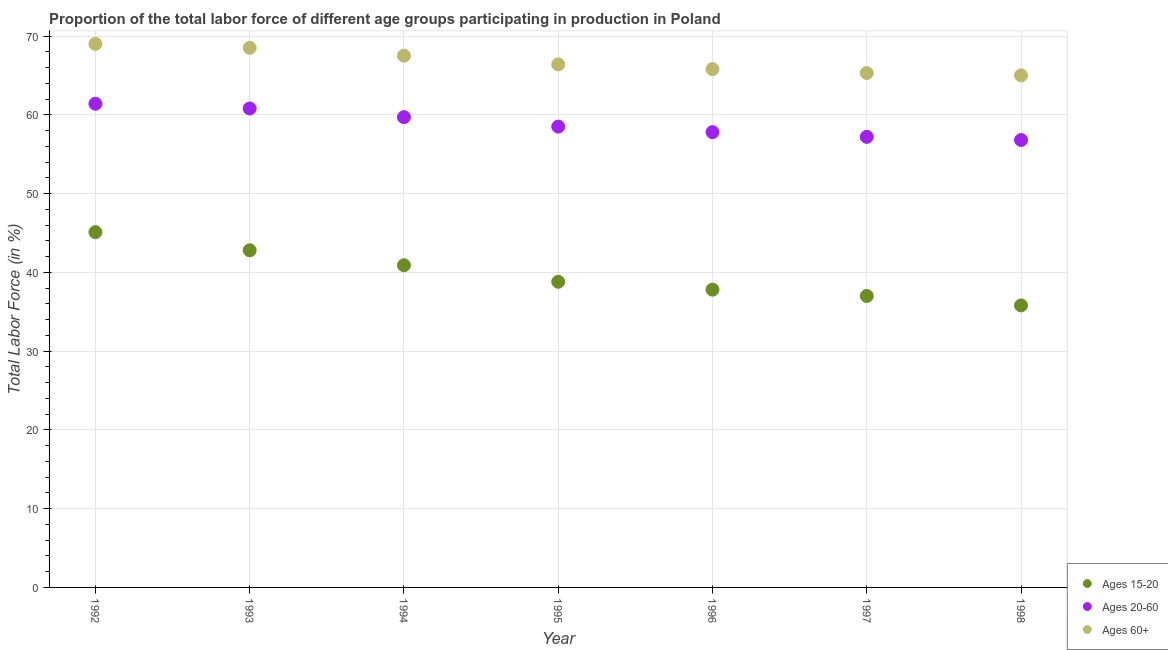What is the percentage of labor force above age 60 in 1996?
Give a very brief answer. 65.8. Across all years, what is the maximum percentage of labor force within the age group 15-20?
Keep it short and to the point. 45.1. Across all years, what is the minimum percentage of labor force within the age group 15-20?
Your response must be concise. 35.8. What is the total percentage of labor force within the age group 20-60 in the graph?
Provide a succinct answer. 412.2. What is the difference between the percentage of labor force within the age group 15-20 in 1994 and that in 1996?
Ensure brevity in your answer.  3.1. What is the difference between the percentage of labor force within the age group 15-20 in 1997 and the percentage of labor force above age 60 in 1994?
Offer a terse response. -30.5. What is the average percentage of labor force within the age group 20-60 per year?
Your answer should be very brief. 58.89. In the year 1997, what is the difference between the percentage of labor force above age 60 and percentage of labor force within the age group 15-20?
Ensure brevity in your answer.  28.3. In how many years, is the percentage of labor force above age 60 greater than 54 %?
Ensure brevity in your answer.  7. What is the ratio of the percentage of labor force within the age group 15-20 in 1993 to that in 1997?
Ensure brevity in your answer.  1.16. Is the percentage of labor force within the age group 15-20 in 1996 less than that in 1998?
Make the answer very short. No. What is the difference between the highest and the second highest percentage of labor force within the age group 15-20?
Your response must be concise. 2.3. What is the difference between the highest and the lowest percentage of labor force above age 60?
Provide a succinct answer. 4. Is the sum of the percentage of labor force within the age group 20-60 in 1994 and 1995 greater than the maximum percentage of labor force above age 60 across all years?
Provide a succinct answer. Yes. Does the percentage of labor force above age 60 monotonically increase over the years?
Keep it short and to the point. No. Is the percentage of labor force above age 60 strictly less than the percentage of labor force within the age group 20-60 over the years?
Your response must be concise. No. How many years are there in the graph?
Ensure brevity in your answer.  7. How are the legend labels stacked?
Your response must be concise. Vertical. What is the title of the graph?
Offer a terse response. Proportion of the total labor force of different age groups participating in production in Poland. Does "Social Protection and Labor" appear as one of the legend labels in the graph?
Offer a very short reply. No. What is the Total Labor Force (in %) in Ages 15-20 in 1992?
Make the answer very short. 45.1. What is the Total Labor Force (in %) in Ages 20-60 in 1992?
Your answer should be very brief. 61.4. What is the Total Labor Force (in %) of Ages 15-20 in 1993?
Your answer should be compact. 42.8. What is the Total Labor Force (in %) in Ages 20-60 in 1993?
Provide a succinct answer. 60.8. What is the Total Labor Force (in %) of Ages 60+ in 1993?
Give a very brief answer. 68.5. What is the Total Labor Force (in %) of Ages 15-20 in 1994?
Your answer should be compact. 40.9. What is the Total Labor Force (in %) in Ages 20-60 in 1994?
Give a very brief answer. 59.7. What is the Total Labor Force (in %) of Ages 60+ in 1994?
Provide a succinct answer. 67.5. What is the Total Labor Force (in %) in Ages 15-20 in 1995?
Ensure brevity in your answer.  38.8. What is the Total Labor Force (in %) of Ages 20-60 in 1995?
Make the answer very short. 58.5. What is the Total Labor Force (in %) in Ages 60+ in 1995?
Provide a short and direct response. 66.4. What is the Total Labor Force (in %) of Ages 15-20 in 1996?
Offer a terse response. 37.8. What is the Total Labor Force (in %) of Ages 20-60 in 1996?
Offer a terse response. 57.8. What is the Total Labor Force (in %) of Ages 60+ in 1996?
Offer a very short reply. 65.8. What is the Total Labor Force (in %) in Ages 15-20 in 1997?
Make the answer very short. 37. What is the Total Labor Force (in %) of Ages 20-60 in 1997?
Offer a terse response. 57.2. What is the Total Labor Force (in %) in Ages 60+ in 1997?
Your answer should be very brief. 65.3. What is the Total Labor Force (in %) in Ages 15-20 in 1998?
Make the answer very short. 35.8. What is the Total Labor Force (in %) in Ages 20-60 in 1998?
Offer a terse response. 56.8. Across all years, what is the maximum Total Labor Force (in %) of Ages 15-20?
Provide a short and direct response. 45.1. Across all years, what is the maximum Total Labor Force (in %) in Ages 20-60?
Provide a short and direct response. 61.4. Across all years, what is the minimum Total Labor Force (in %) of Ages 15-20?
Your answer should be very brief. 35.8. Across all years, what is the minimum Total Labor Force (in %) of Ages 20-60?
Provide a short and direct response. 56.8. What is the total Total Labor Force (in %) in Ages 15-20 in the graph?
Provide a succinct answer. 278.2. What is the total Total Labor Force (in %) in Ages 20-60 in the graph?
Provide a short and direct response. 412.2. What is the total Total Labor Force (in %) in Ages 60+ in the graph?
Keep it short and to the point. 467.5. What is the difference between the Total Labor Force (in %) of Ages 15-20 in 1992 and that in 1993?
Your answer should be compact. 2.3. What is the difference between the Total Labor Force (in %) of Ages 60+ in 1992 and that in 1993?
Keep it short and to the point. 0.5. What is the difference between the Total Labor Force (in %) of Ages 15-20 in 1992 and that in 1994?
Offer a terse response. 4.2. What is the difference between the Total Labor Force (in %) in Ages 20-60 in 1992 and that in 1994?
Your response must be concise. 1.7. What is the difference between the Total Labor Force (in %) of Ages 60+ in 1992 and that in 1994?
Offer a terse response. 1.5. What is the difference between the Total Labor Force (in %) of Ages 20-60 in 1992 and that in 1996?
Give a very brief answer. 3.6. What is the difference between the Total Labor Force (in %) of Ages 60+ in 1992 and that in 1996?
Your response must be concise. 3.2. What is the difference between the Total Labor Force (in %) of Ages 15-20 in 1992 and that in 1998?
Offer a very short reply. 9.3. What is the difference between the Total Labor Force (in %) in Ages 20-60 in 1992 and that in 1998?
Provide a succinct answer. 4.6. What is the difference between the Total Labor Force (in %) of Ages 15-20 in 1993 and that in 1994?
Give a very brief answer. 1.9. What is the difference between the Total Labor Force (in %) of Ages 60+ in 1993 and that in 1994?
Make the answer very short. 1. What is the difference between the Total Labor Force (in %) of Ages 15-20 in 1993 and that in 1996?
Offer a terse response. 5. What is the difference between the Total Labor Force (in %) of Ages 60+ in 1993 and that in 1996?
Keep it short and to the point. 2.7. What is the difference between the Total Labor Force (in %) in Ages 20-60 in 1993 and that in 1997?
Your answer should be compact. 3.6. What is the difference between the Total Labor Force (in %) of Ages 60+ in 1993 and that in 1997?
Make the answer very short. 3.2. What is the difference between the Total Labor Force (in %) of Ages 15-20 in 1993 and that in 1998?
Make the answer very short. 7. What is the difference between the Total Labor Force (in %) in Ages 20-60 in 1994 and that in 1995?
Give a very brief answer. 1.2. What is the difference between the Total Labor Force (in %) in Ages 60+ in 1994 and that in 1995?
Your response must be concise. 1.1. What is the difference between the Total Labor Force (in %) of Ages 20-60 in 1994 and that in 1996?
Make the answer very short. 1.9. What is the difference between the Total Labor Force (in %) of Ages 60+ in 1994 and that in 1996?
Offer a very short reply. 1.7. What is the difference between the Total Labor Force (in %) in Ages 20-60 in 1994 and that in 1997?
Offer a terse response. 2.5. What is the difference between the Total Labor Force (in %) of Ages 15-20 in 1994 and that in 1998?
Provide a short and direct response. 5.1. What is the difference between the Total Labor Force (in %) in Ages 60+ in 1995 and that in 1996?
Offer a very short reply. 0.6. What is the difference between the Total Labor Force (in %) of Ages 15-20 in 1995 and that in 1998?
Your answer should be very brief. 3. What is the difference between the Total Labor Force (in %) in Ages 20-60 in 1995 and that in 1998?
Give a very brief answer. 1.7. What is the difference between the Total Labor Force (in %) of Ages 60+ in 1995 and that in 1998?
Keep it short and to the point. 1.4. What is the difference between the Total Labor Force (in %) of Ages 15-20 in 1996 and that in 1997?
Offer a terse response. 0.8. What is the difference between the Total Labor Force (in %) of Ages 15-20 in 1996 and that in 1998?
Your answer should be very brief. 2. What is the difference between the Total Labor Force (in %) of Ages 20-60 in 1996 and that in 1998?
Provide a succinct answer. 1. What is the difference between the Total Labor Force (in %) of Ages 60+ in 1996 and that in 1998?
Your answer should be very brief. 0.8. What is the difference between the Total Labor Force (in %) of Ages 15-20 in 1997 and that in 1998?
Provide a short and direct response. 1.2. What is the difference between the Total Labor Force (in %) in Ages 60+ in 1997 and that in 1998?
Make the answer very short. 0.3. What is the difference between the Total Labor Force (in %) in Ages 15-20 in 1992 and the Total Labor Force (in %) in Ages 20-60 in 1993?
Your response must be concise. -15.7. What is the difference between the Total Labor Force (in %) of Ages 15-20 in 1992 and the Total Labor Force (in %) of Ages 60+ in 1993?
Offer a terse response. -23.4. What is the difference between the Total Labor Force (in %) of Ages 15-20 in 1992 and the Total Labor Force (in %) of Ages 20-60 in 1994?
Your answer should be compact. -14.6. What is the difference between the Total Labor Force (in %) in Ages 15-20 in 1992 and the Total Labor Force (in %) in Ages 60+ in 1994?
Provide a succinct answer. -22.4. What is the difference between the Total Labor Force (in %) of Ages 20-60 in 1992 and the Total Labor Force (in %) of Ages 60+ in 1994?
Make the answer very short. -6.1. What is the difference between the Total Labor Force (in %) of Ages 15-20 in 1992 and the Total Labor Force (in %) of Ages 60+ in 1995?
Your response must be concise. -21.3. What is the difference between the Total Labor Force (in %) of Ages 15-20 in 1992 and the Total Labor Force (in %) of Ages 60+ in 1996?
Provide a succinct answer. -20.7. What is the difference between the Total Labor Force (in %) in Ages 15-20 in 1992 and the Total Labor Force (in %) in Ages 60+ in 1997?
Provide a succinct answer. -20.2. What is the difference between the Total Labor Force (in %) in Ages 15-20 in 1992 and the Total Labor Force (in %) in Ages 20-60 in 1998?
Your answer should be compact. -11.7. What is the difference between the Total Labor Force (in %) in Ages 15-20 in 1992 and the Total Labor Force (in %) in Ages 60+ in 1998?
Your answer should be very brief. -19.9. What is the difference between the Total Labor Force (in %) in Ages 20-60 in 1992 and the Total Labor Force (in %) in Ages 60+ in 1998?
Your answer should be compact. -3.6. What is the difference between the Total Labor Force (in %) in Ages 15-20 in 1993 and the Total Labor Force (in %) in Ages 20-60 in 1994?
Make the answer very short. -16.9. What is the difference between the Total Labor Force (in %) of Ages 15-20 in 1993 and the Total Labor Force (in %) of Ages 60+ in 1994?
Your response must be concise. -24.7. What is the difference between the Total Labor Force (in %) in Ages 15-20 in 1993 and the Total Labor Force (in %) in Ages 20-60 in 1995?
Give a very brief answer. -15.7. What is the difference between the Total Labor Force (in %) of Ages 15-20 in 1993 and the Total Labor Force (in %) of Ages 60+ in 1995?
Ensure brevity in your answer.  -23.6. What is the difference between the Total Labor Force (in %) of Ages 15-20 in 1993 and the Total Labor Force (in %) of Ages 20-60 in 1996?
Give a very brief answer. -15. What is the difference between the Total Labor Force (in %) of Ages 20-60 in 1993 and the Total Labor Force (in %) of Ages 60+ in 1996?
Make the answer very short. -5. What is the difference between the Total Labor Force (in %) in Ages 15-20 in 1993 and the Total Labor Force (in %) in Ages 20-60 in 1997?
Offer a terse response. -14.4. What is the difference between the Total Labor Force (in %) in Ages 15-20 in 1993 and the Total Labor Force (in %) in Ages 60+ in 1997?
Keep it short and to the point. -22.5. What is the difference between the Total Labor Force (in %) of Ages 15-20 in 1993 and the Total Labor Force (in %) of Ages 60+ in 1998?
Your response must be concise. -22.2. What is the difference between the Total Labor Force (in %) in Ages 15-20 in 1994 and the Total Labor Force (in %) in Ages 20-60 in 1995?
Ensure brevity in your answer.  -17.6. What is the difference between the Total Labor Force (in %) of Ages 15-20 in 1994 and the Total Labor Force (in %) of Ages 60+ in 1995?
Ensure brevity in your answer.  -25.5. What is the difference between the Total Labor Force (in %) in Ages 15-20 in 1994 and the Total Labor Force (in %) in Ages 20-60 in 1996?
Keep it short and to the point. -16.9. What is the difference between the Total Labor Force (in %) of Ages 15-20 in 1994 and the Total Labor Force (in %) of Ages 60+ in 1996?
Offer a very short reply. -24.9. What is the difference between the Total Labor Force (in %) of Ages 15-20 in 1994 and the Total Labor Force (in %) of Ages 20-60 in 1997?
Ensure brevity in your answer.  -16.3. What is the difference between the Total Labor Force (in %) of Ages 15-20 in 1994 and the Total Labor Force (in %) of Ages 60+ in 1997?
Make the answer very short. -24.4. What is the difference between the Total Labor Force (in %) in Ages 20-60 in 1994 and the Total Labor Force (in %) in Ages 60+ in 1997?
Your answer should be compact. -5.6. What is the difference between the Total Labor Force (in %) of Ages 15-20 in 1994 and the Total Labor Force (in %) of Ages 20-60 in 1998?
Your response must be concise. -15.9. What is the difference between the Total Labor Force (in %) in Ages 15-20 in 1994 and the Total Labor Force (in %) in Ages 60+ in 1998?
Give a very brief answer. -24.1. What is the difference between the Total Labor Force (in %) of Ages 15-20 in 1995 and the Total Labor Force (in %) of Ages 60+ in 1996?
Provide a short and direct response. -27. What is the difference between the Total Labor Force (in %) in Ages 15-20 in 1995 and the Total Labor Force (in %) in Ages 20-60 in 1997?
Your answer should be compact. -18.4. What is the difference between the Total Labor Force (in %) in Ages 15-20 in 1995 and the Total Labor Force (in %) in Ages 60+ in 1997?
Your response must be concise. -26.5. What is the difference between the Total Labor Force (in %) in Ages 15-20 in 1995 and the Total Labor Force (in %) in Ages 20-60 in 1998?
Your response must be concise. -18. What is the difference between the Total Labor Force (in %) in Ages 15-20 in 1995 and the Total Labor Force (in %) in Ages 60+ in 1998?
Provide a short and direct response. -26.2. What is the difference between the Total Labor Force (in %) in Ages 20-60 in 1995 and the Total Labor Force (in %) in Ages 60+ in 1998?
Ensure brevity in your answer.  -6.5. What is the difference between the Total Labor Force (in %) of Ages 15-20 in 1996 and the Total Labor Force (in %) of Ages 20-60 in 1997?
Make the answer very short. -19.4. What is the difference between the Total Labor Force (in %) in Ages 15-20 in 1996 and the Total Labor Force (in %) in Ages 60+ in 1997?
Keep it short and to the point. -27.5. What is the difference between the Total Labor Force (in %) of Ages 15-20 in 1996 and the Total Labor Force (in %) of Ages 20-60 in 1998?
Ensure brevity in your answer.  -19. What is the difference between the Total Labor Force (in %) in Ages 15-20 in 1996 and the Total Labor Force (in %) in Ages 60+ in 1998?
Offer a very short reply. -27.2. What is the difference between the Total Labor Force (in %) of Ages 15-20 in 1997 and the Total Labor Force (in %) of Ages 20-60 in 1998?
Provide a succinct answer. -19.8. What is the difference between the Total Labor Force (in %) in Ages 15-20 in 1997 and the Total Labor Force (in %) in Ages 60+ in 1998?
Provide a short and direct response. -28. What is the difference between the Total Labor Force (in %) of Ages 20-60 in 1997 and the Total Labor Force (in %) of Ages 60+ in 1998?
Your answer should be very brief. -7.8. What is the average Total Labor Force (in %) in Ages 15-20 per year?
Ensure brevity in your answer.  39.74. What is the average Total Labor Force (in %) in Ages 20-60 per year?
Your response must be concise. 58.89. What is the average Total Labor Force (in %) of Ages 60+ per year?
Offer a very short reply. 66.79. In the year 1992, what is the difference between the Total Labor Force (in %) of Ages 15-20 and Total Labor Force (in %) of Ages 20-60?
Ensure brevity in your answer.  -16.3. In the year 1992, what is the difference between the Total Labor Force (in %) in Ages 15-20 and Total Labor Force (in %) in Ages 60+?
Provide a succinct answer. -23.9. In the year 1992, what is the difference between the Total Labor Force (in %) of Ages 20-60 and Total Labor Force (in %) of Ages 60+?
Ensure brevity in your answer.  -7.6. In the year 1993, what is the difference between the Total Labor Force (in %) in Ages 15-20 and Total Labor Force (in %) in Ages 60+?
Provide a short and direct response. -25.7. In the year 1993, what is the difference between the Total Labor Force (in %) in Ages 20-60 and Total Labor Force (in %) in Ages 60+?
Your answer should be compact. -7.7. In the year 1994, what is the difference between the Total Labor Force (in %) in Ages 15-20 and Total Labor Force (in %) in Ages 20-60?
Ensure brevity in your answer.  -18.8. In the year 1994, what is the difference between the Total Labor Force (in %) in Ages 15-20 and Total Labor Force (in %) in Ages 60+?
Provide a short and direct response. -26.6. In the year 1994, what is the difference between the Total Labor Force (in %) of Ages 20-60 and Total Labor Force (in %) of Ages 60+?
Ensure brevity in your answer.  -7.8. In the year 1995, what is the difference between the Total Labor Force (in %) of Ages 15-20 and Total Labor Force (in %) of Ages 20-60?
Make the answer very short. -19.7. In the year 1995, what is the difference between the Total Labor Force (in %) in Ages 15-20 and Total Labor Force (in %) in Ages 60+?
Make the answer very short. -27.6. In the year 1995, what is the difference between the Total Labor Force (in %) in Ages 20-60 and Total Labor Force (in %) in Ages 60+?
Keep it short and to the point. -7.9. In the year 1996, what is the difference between the Total Labor Force (in %) in Ages 20-60 and Total Labor Force (in %) in Ages 60+?
Your answer should be compact. -8. In the year 1997, what is the difference between the Total Labor Force (in %) of Ages 15-20 and Total Labor Force (in %) of Ages 20-60?
Your response must be concise. -20.2. In the year 1997, what is the difference between the Total Labor Force (in %) of Ages 15-20 and Total Labor Force (in %) of Ages 60+?
Make the answer very short. -28.3. In the year 1997, what is the difference between the Total Labor Force (in %) of Ages 20-60 and Total Labor Force (in %) of Ages 60+?
Ensure brevity in your answer.  -8.1. In the year 1998, what is the difference between the Total Labor Force (in %) in Ages 15-20 and Total Labor Force (in %) in Ages 60+?
Ensure brevity in your answer.  -29.2. What is the ratio of the Total Labor Force (in %) of Ages 15-20 in 1992 to that in 1993?
Offer a terse response. 1.05. What is the ratio of the Total Labor Force (in %) in Ages 20-60 in 1992 to that in 1993?
Your response must be concise. 1.01. What is the ratio of the Total Labor Force (in %) in Ages 60+ in 1992 to that in 1993?
Provide a short and direct response. 1.01. What is the ratio of the Total Labor Force (in %) of Ages 15-20 in 1992 to that in 1994?
Provide a succinct answer. 1.1. What is the ratio of the Total Labor Force (in %) of Ages 20-60 in 1992 to that in 1994?
Provide a short and direct response. 1.03. What is the ratio of the Total Labor Force (in %) in Ages 60+ in 1992 to that in 1994?
Your response must be concise. 1.02. What is the ratio of the Total Labor Force (in %) of Ages 15-20 in 1992 to that in 1995?
Provide a succinct answer. 1.16. What is the ratio of the Total Labor Force (in %) of Ages 20-60 in 1992 to that in 1995?
Offer a very short reply. 1.05. What is the ratio of the Total Labor Force (in %) in Ages 60+ in 1992 to that in 1995?
Offer a very short reply. 1.04. What is the ratio of the Total Labor Force (in %) of Ages 15-20 in 1992 to that in 1996?
Give a very brief answer. 1.19. What is the ratio of the Total Labor Force (in %) of Ages 20-60 in 1992 to that in 1996?
Your answer should be very brief. 1.06. What is the ratio of the Total Labor Force (in %) in Ages 60+ in 1992 to that in 1996?
Keep it short and to the point. 1.05. What is the ratio of the Total Labor Force (in %) in Ages 15-20 in 1992 to that in 1997?
Your response must be concise. 1.22. What is the ratio of the Total Labor Force (in %) in Ages 20-60 in 1992 to that in 1997?
Make the answer very short. 1.07. What is the ratio of the Total Labor Force (in %) in Ages 60+ in 1992 to that in 1997?
Offer a terse response. 1.06. What is the ratio of the Total Labor Force (in %) of Ages 15-20 in 1992 to that in 1998?
Make the answer very short. 1.26. What is the ratio of the Total Labor Force (in %) in Ages 20-60 in 1992 to that in 1998?
Offer a very short reply. 1.08. What is the ratio of the Total Labor Force (in %) in Ages 60+ in 1992 to that in 1998?
Give a very brief answer. 1.06. What is the ratio of the Total Labor Force (in %) in Ages 15-20 in 1993 to that in 1994?
Keep it short and to the point. 1.05. What is the ratio of the Total Labor Force (in %) of Ages 20-60 in 1993 to that in 1994?
Offer a very short reply. 1.02. What is the ratio of the Total Labor Force (in %) in Ages 60+ in 1993 to that in 1994?
Make the answer very short. 1.01. What is the ratio of the Total Labor Force (in %) in Ages 15-20 in 1993 to that in 1995?
Offer a very short reply. 1.1. What is the ratio of the Total Labor Force (in %) of Ages 20-60 in 1993 to that in 1995?
Keep it short and to the point. 1.04. What is the ratio of the Total Labor Force (in %) in Ages 60+ in 1993 to that in 1995?
Ensure brevity in your answer.  1.03. What is the ratio of the Total Labor Force (in %) of Ages 15-20 in 1993 to that in 1996?
Keep it short and to the point. 1.13. What is the ratio of the Total Labor Force (in %) of Ages 20-60 in 1993 to that in 1996?
Ensure brevity in your answer.  1.05. What is the ratio of the Total Labor Force (in %) in Ages 60+ in 1993 to that in 1996?
Give a very brief answer. 1.04. What is the ratio of the Total Labor Force (in %) of Ages 15-20 in 1993 to that in 1997?
Keep it short and to the point. 1.16. What is the ratio of the Total Labor Force (in %) of Ages 20-60 in 1993 to that in 1997?
Ensure brevity in your answer.  1.06. What is the ratio of the Total Labor Force (in %) in Ages 60+ in 1993 to that in 1997?
Offer a terse response. 1.05. What is the ratio of the Total Labor Force (in %) of Ages 15-20 in 1993 to that in 1998?
Your answer should be very brief. 1.2. What is the ratio of the Total Labor Force (in %) of Ages 20-60 in 1993 to that in 1998?
Provide a short and direct response. 1.07. What is the ratio of the Total Labor Force (in %) in Ages 60+ in 1993 to that in 1998?
Your response must be concise. 1.05. What is the ratio of the Total Labor Force (in %) in Ages 15-20 in 1994 to that in 1995?
Ensure brevity in your answer.  1.05. What is the ratio of the Total Labor Force (in %) in Ages 20-60 in 1994 to that in 1995?
Provide a short and direct response. 1.02. What is the ratio of the Total Labor Force (in %) of Ages 60+ in 1994 to that in 1995?
Provide a short and direct response. 1.02. What is the ratio of the Total Labor Force (in %) in Ages 15-20 in 1994 to that in 1996?
Your response must be concise. 1.08. What is the ratio of the Total Labor Force (in %) in Ages 20-60 in 1994 to that in 1996?
Offer a very short reply. 1.03. What is the ratio of the Total Labor Force (in %) of Ages 60+ in 1994 to that in 1996?
Provide a succinct answer. 1.03. What is the ratio of the Total Labor Force (in %) in Ages 15-20 in 1994 to that in 1997?
Ensure brevity in your answer.  1.11. What is the ratio of the Total Labor Force (in %) of Ages 20-60 in 1994 to that in 1997?
Your response must be concise. 1.04. What is the ratio of the Total Labor Force (in %) in Ages 60+ in 1994 to that in 1997?
Your response must be concise. 1.03. What is the ratio of the Total Labor Force (in %) in Ages 15-20 in 1994 to that in 1998?
Your answer should be compact. 1.14. What is the ratio of the Total Labor Force (in %) in Ages 20-60 in 1994 to that in 1998?
Keep it short and to the point. 1.05. What is the ratio of the Total Labor Force (in %) of Ages 60+ in 1994 to that in 1998?
Your response must be concise. 1.04. What is the ratio of the Total Labor Force (in %) in Ages 15-20 in 1995 to that in 1996?
Provide a short and direct response. 1.03. What is the ratio of the Total Labor Force (in %) in Ages 20-60 in 1995 to that in 1996?
Make the answer very short. 1.01. What is the ratio of the Total Labor Force (in %) of Ages 60+ in 1995 to that in 1996?
Your response must be concise. 1.01. What is the ratio of the Total Labor Force (in %) in Ages 15-20 in 1995 to that in 1997?
Your response must be concise. 1.05. What is the ratio of the Total Labor Force (in %) of Ages 20-60 in 1995 to that in 1997?
Keep it short and to the point. 1.02. What is the ratio of the Total Labor Force (in %) in Ages 60+ in 1995 to that in 1997?
Make the answer very short. 1.02. What is the ratio of the Total Labor Force (in %) in Ages 15-20 in 1995 to that in 1998?
Your answer should be compact. 1.08. What is the ratio of the Total Labor Force (in %) in Ages 20-60 in 1995 to that in 1998?
Ensure brevity in your answer.  1.03. What is the ratio of the Total Labor Force (in %) of Ages 60+ in 1995 to that in 1998?
Give a very brief answer. 1.02. What is the ratio of the Total Labor Force (in %) in Ages 15-20 in 1996 to that in 1997?
Offer a terse response. 1.02. What is the ratio of the Total Labor Force (in %) of Ages 20-60 in 1996 to that in 1997?
Provide a short and direct response. 1.01. What is the ratio of the Total Labor Force (in %) in Ages 60+ in 1996 to that in 1997?
Give a very brief answer. 1.01. What is the ratio of the Total Labor Force (in %) in Ages 15-20 in 1996 to that in 1998?
Your answer should be very brief. 1.06. What is the ratio of the Total Labor Force (in %) in Ages 20-60 in 1996 to that in 1998?
Ensure brevity in your answer.  1.02. What is the ratio of the Total Labor Force (in %) in Ages 60+ in 1996 to that in 1998?
Your answer should be very brief. 1.01. What is the ratio of the Total Labor Force (in %) of Ages 15-20 in 1997 to that in 1998?
Your response must be concise. 1.03. What is the ratio of the Total Labor Force (in %) in Ages 20-60 in 1997 to that in 1998?
Your response must be concise. 1.01. What is the difference between the highest and the second highest Total Labor Force (in %) of Ages 15-20?
Your answer should be very brief. 2.3. What is the difference between the highest and the second highest Total Labor Force (in %) in Ages 60+?
Give a very brief answer. 0.5. What is the difference between the highest and the lowest Total Labor Force (in %) in Ages 15-20?
Your answer should be compact. 9.3. What is the difference between the highest and the lowest Total Labor Force (in %) in Ages 60+?
Your answer should be very brief. 4. 